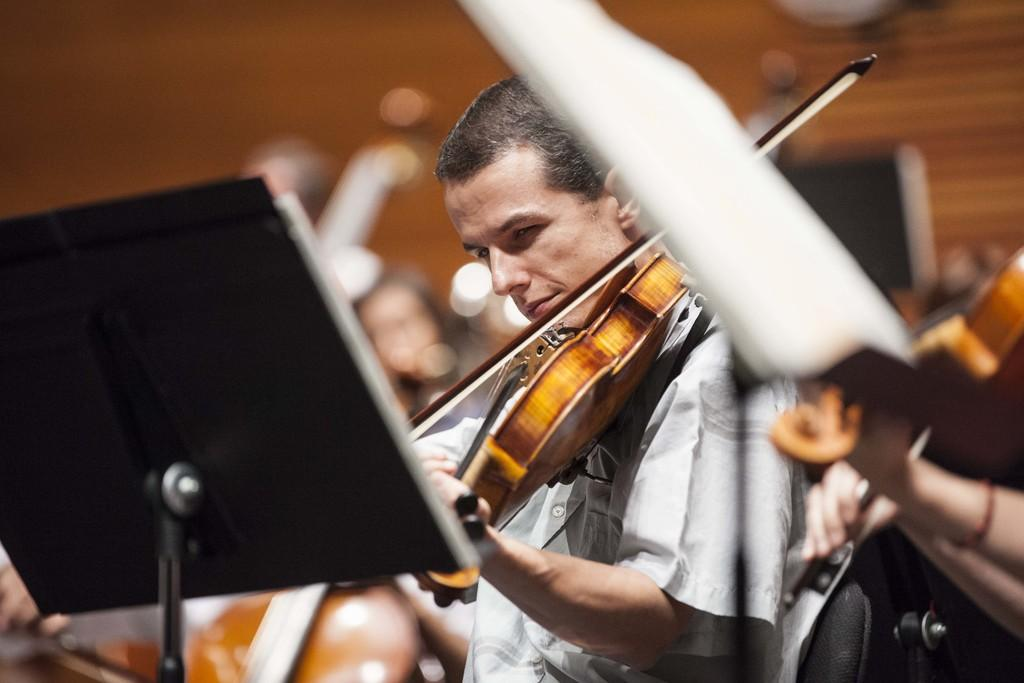Who is the main subject in the image? There is a man in the image. What is the man holding in the image? The man is holding a violin. What is the man doing with the violin? The man is playing the violin. What object is present in front of the man for support? There is a stand for placing a book in front of the man. What can be seen in the background of the image? There is a wall in the background of the image. What type of machine is being used to stitch the man's clothes in the image? There is no machine present in the image, nor is there any indication that the man's clothes are being stitched. 